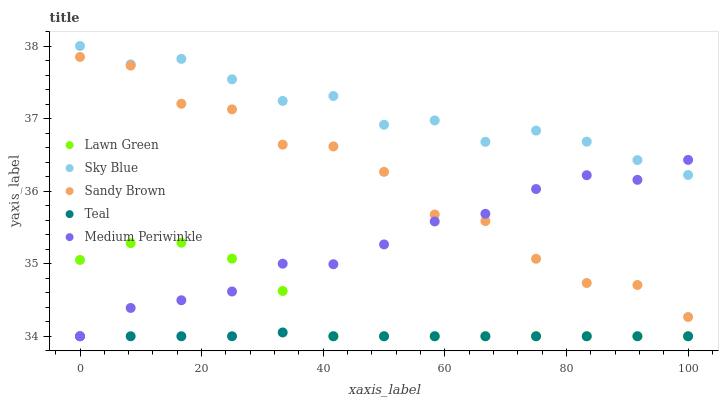Does Teal have the minimum area under the curve?
Answer yes or no. Yes. Does Sky Blue have the maximum area under the curve?
Answer yes or no. Yes. Does Sandy Brown have the minimum area under the curve?
Answer yes or no. No. Does Sandy Brown have the maximum area under the curve?
Answer yes or no. No. Is Teal the smoothest?
Answer yes or no. Yes. Is Sandy Brown the roughest?
Answer yes or no. Yes. Is Medium Periwinkle the smoothest?
Answer yes or no. No. Is Medium Periwinkle the roughest?
Answer yes or no. No. Does Lawn Green have the lowest value?
Answer yes or no. Yes. Does Sandy Brown have the lowest value?
Answer yes or no. No. Does Sky Blue have the highest value?
Answer yes or no. Yes. Does Sandy Brown have the highest value?
Answer yes or no. No. Is Teal less than Sandy Brown?
Answer yes or no. Yes. Is Sky Blue greater than Teal?
Answer yes or no. Yes. Does Teal intersect Medium Periwinkle?
Answer yes or no. Yes. Is Teal less than Medium Periwinkle?
Answer yes or no. No. Is Teal greater than Medium Periwinkle?
Answer yes or no. No. Does Teal intersect Sandy Brown?
Answer yes or no. No. 